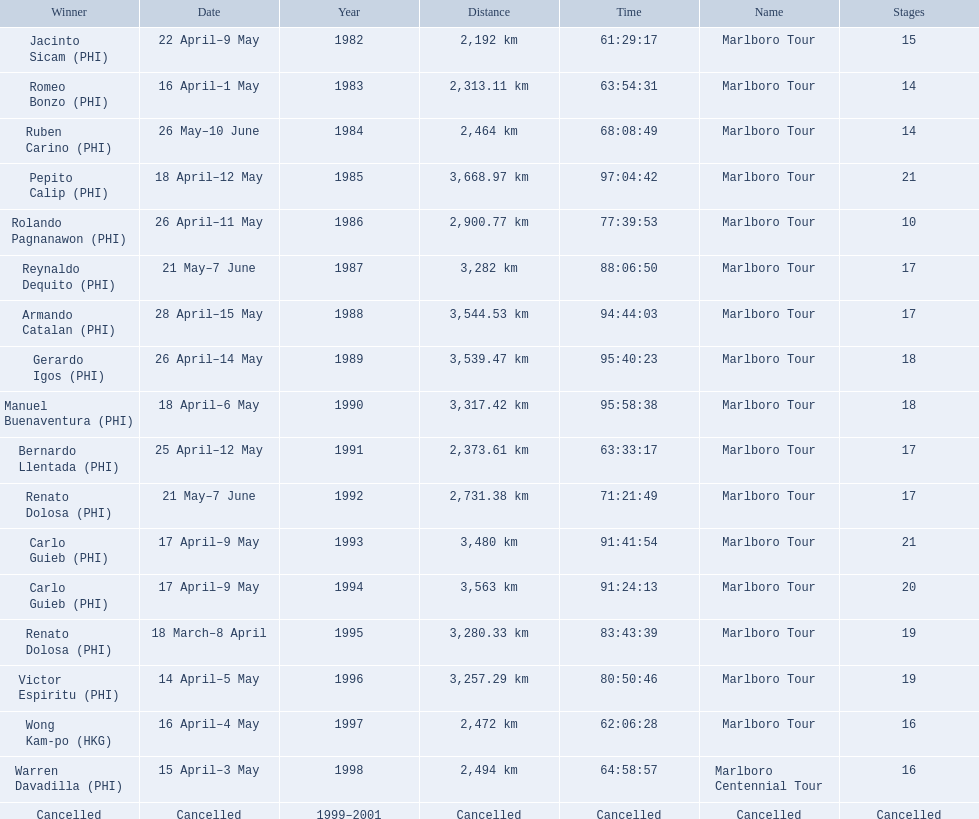What race did warren davadilla compete in in 1998? Marlboro Centennial Tour. How long did it take davadilla to complete the marlboro centennial tour? 64:58:57. 